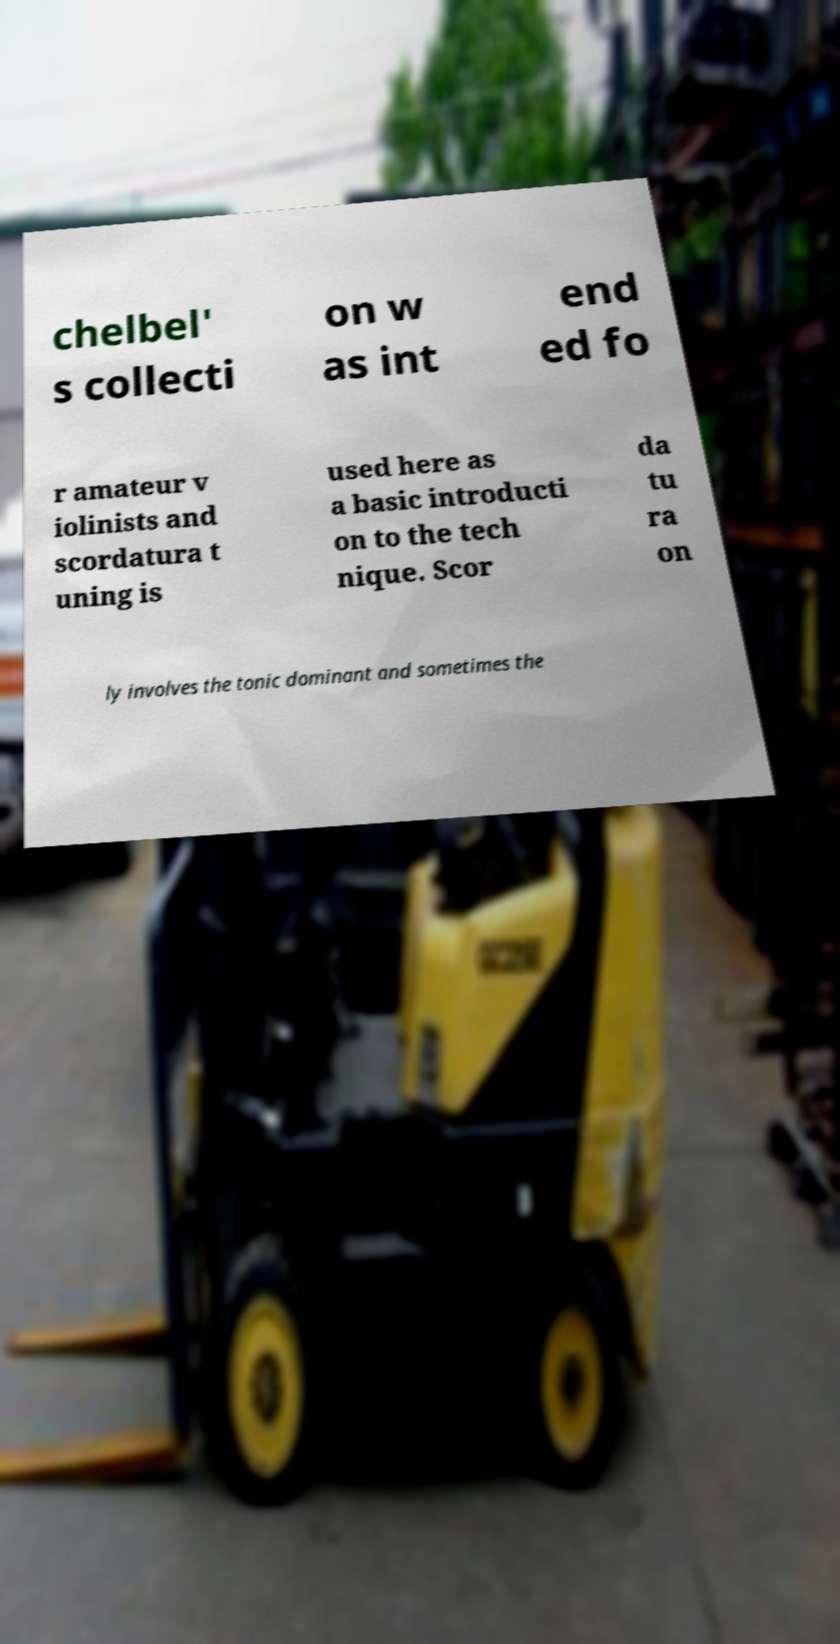Can you read and provide the text displayed in the image?This photo seems to have some interesting text. Can you extract and type it out for me? chelbel' s collecti on w as int end ed fo r amateur v iolinists and scordatura t uning is used here as a basic introducti on to the tech nique. Scor da tu ra on ly involves the tonic dominant and sometimes the 